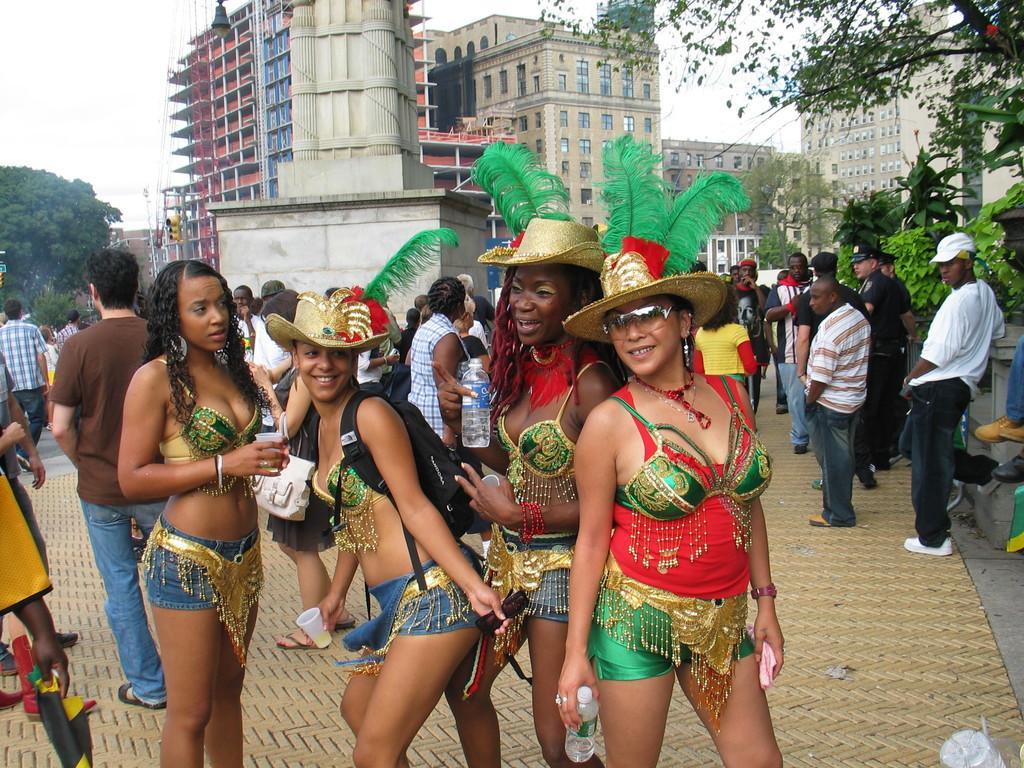Please provide a concise description of this image. In the foreground I can see a crowd on the road. In the background I can see trees, buildings and street lights. On the top I can see the sky. This image is taken during a day on the road. 